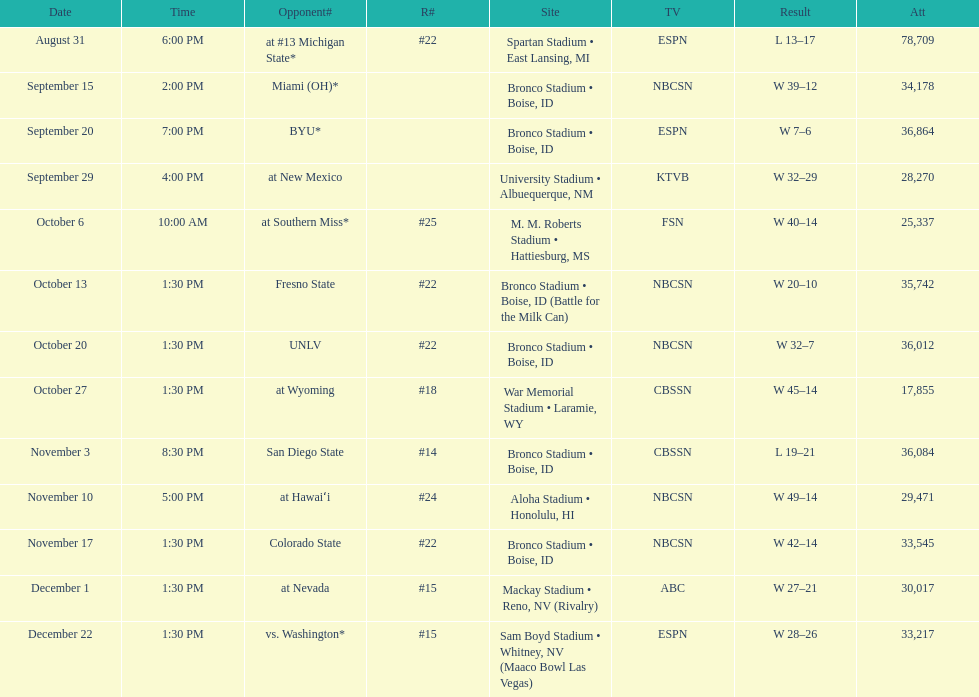Did the broncos on september 29th win by less than 5 points? Yes. Could you parse the entire table? {'header': ['Date', 'Time', 'Opponent#', 'R#', 'Site', 'TV', 'Result', 'Att'], 'rows': [['August 31', '6:00 PM', 'at\xa0#13\xa0Michigan State*', '#22', 'Spartan Stadium • East Lansing, MI', 'ESPN', 'L\xa013–17', '78,709'], ['September 15', '2:00 PM', 'Miami (OH)*', '', 'Bronco Stadium • Boise, ID', 'NBCSN', 'W\xa039–12', '34,178'], ['September 20', '7:00 PM', 'BYU*', '', 'Bronco Stadium • Boise, ID', 'ESPN', 'W\xa07–6', '36,864'], ['September 29', '4:00 PM', 'at\xa0New Mexico', '', 'University Stadium • Albuequerque, NM', 'KTVB', 'W\xa032–29', '28,270'], ['October 6', '10:00 AM', 'at\xa0Southern Miss*', '#25', 'M. M. Roberts Stadium • Hattiesburg, MS', 'FSN', 'W\xa040–14', '25,337'], ['October 13', '1:30 PM', 'Fresno State', '#22', 'Bronco Stadium • Boise, ID (Battle for the Milk Can)', 'NBCSN', 'W\xa020–10', '35,742'], ['October 20', '1:30 PM', 'UNLV', '#22', 'Bronco Stadium • Boise, ID', 'NBCSN', 'W\xa032–7', '36,012'], ['October 27', '1:30 PM', 'at\xa0Wyoming', '#18', 'War Memorial Stadium • Laramie, WY', 'CBSSN', 'W\xa045–14', '17,855'], ['November 3', '8:30 PM', 'San Diego State', '#14', 'Bronco Stadium • Boise, ID', 'CBSSN', 'L\xa019–21', '36,084'], ['November 10', '5:00 PM', 'at\xa0Hawaiʻi', '#24', 'Aloha Stadium • Honolulu, HI', 'NBCSN', 'W\xa049–14', '29,471'], ['November 17', '1:30 PM', 'Colorado State', '#22', 'Bronco Stadium • Boise, ID', 'NBCSN', 'W\xa042–14', '33,545'], ['December 1', '1:30 PM', 'at\xa0Nevada', '#15', 'Mackay Stadium • Reno, NV (Rivalry)', 'ABC', 'W\xa027–21', '30,017'], ['December 22', '1:30 PM', 'vs.\xa0Washington*', '#15', 'Sam Boyd Stadium • Whitney, NV (Maaco Bowl Las Vegas)', 'ESPN', 'W\xa028–26', '33,217']]} 